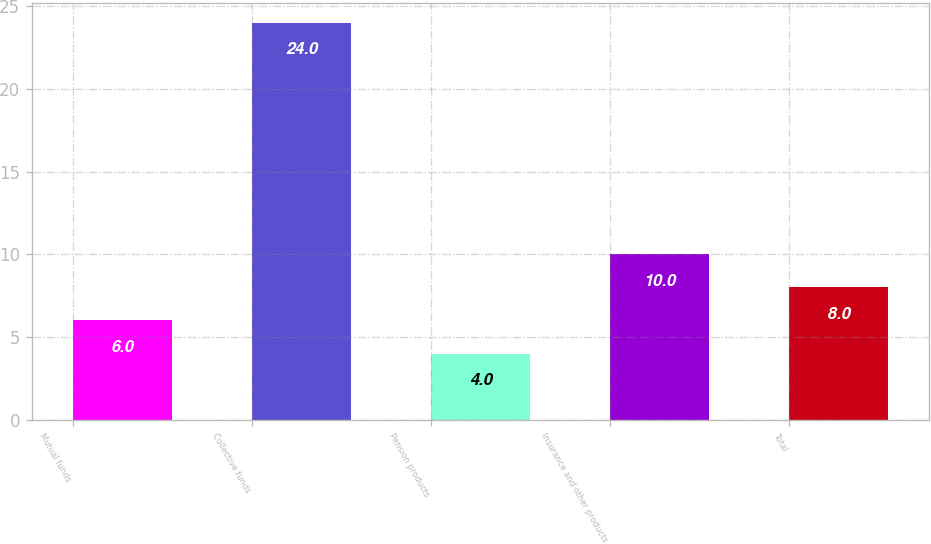Convert chart to OTSL. <chart><loc_0><loc_0><loc_500><loc_500><bar_chart><fcel>Mutual funds<fcel>Collective funds<fcel>Pension products<fcel>Insurance and other products<fcel>Total<nl><fcel>6<fcel>24<fcel>4<fcel>10<fcel>8<nl></chart> 